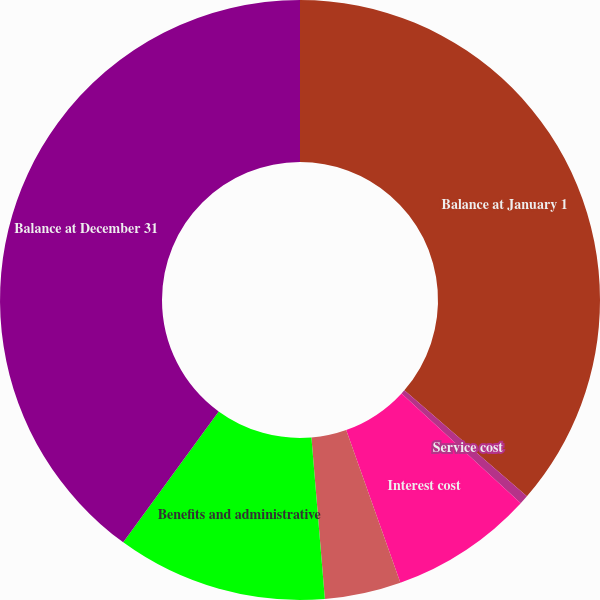<chart> <loc_0><loc_0><loc_500><loc_500><pie_chart><fcel>Balance at January 1<fcel>Service cost<fcel>Interest cost<fcel>Actuarial loss (gain)<fcel>Benefits and administrative<fcel>Balance at December 31<nl><fcel>36.35%<fcel>0.49%<fcel>7.73%<fcel>4.11%<fcel>11.35%<fcel>39.97%<nl></chart> 